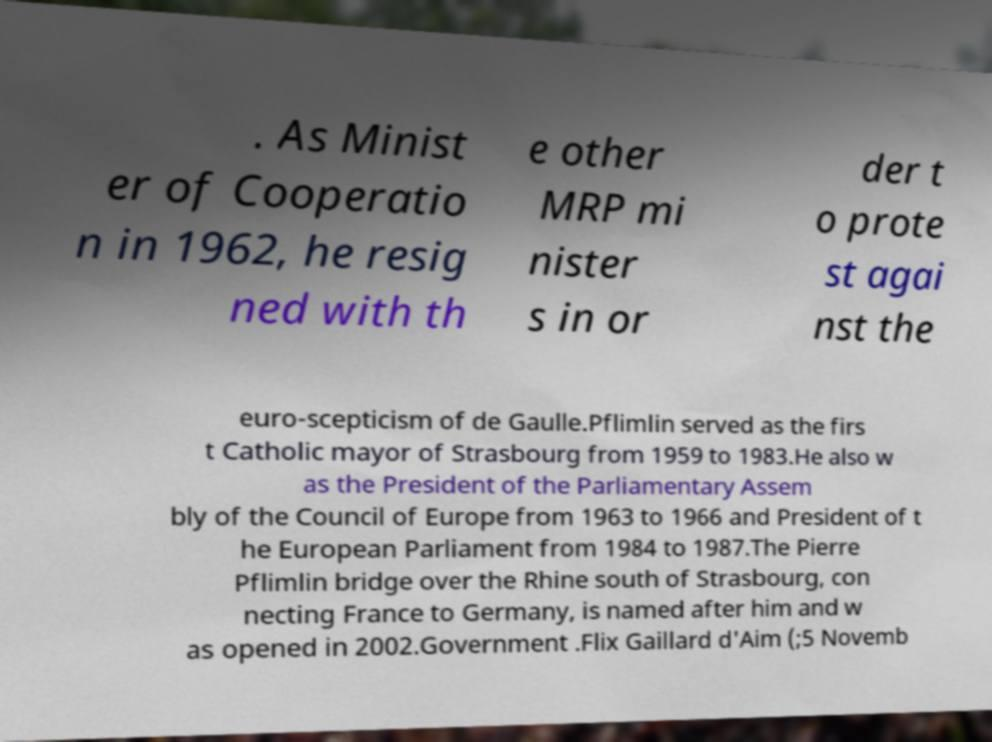Please read and relay the text visible in this image. What does it say? . As Minist er of Cooperatio n in 1962, he resig ned with th e other MRP mi nister s in or der t o prote st agai nst the euro-scepticism of de Gaulle.Pflimlin served as the firs t Catholic mayor of Strasbourg from 1959 to 1983.He also w as the President of the Parliamentary Assem bly of the Council of Europe from 1963 to 1966 and President of t he European Parliament from 1984 to 1987.The Pierre Pflimlin bridge over the Rhine south of Strasbourg, con necting France to Germany, is named after him and w as opened in 2002.Government .Flix Gaillard d'Aim (;5 Novemb 